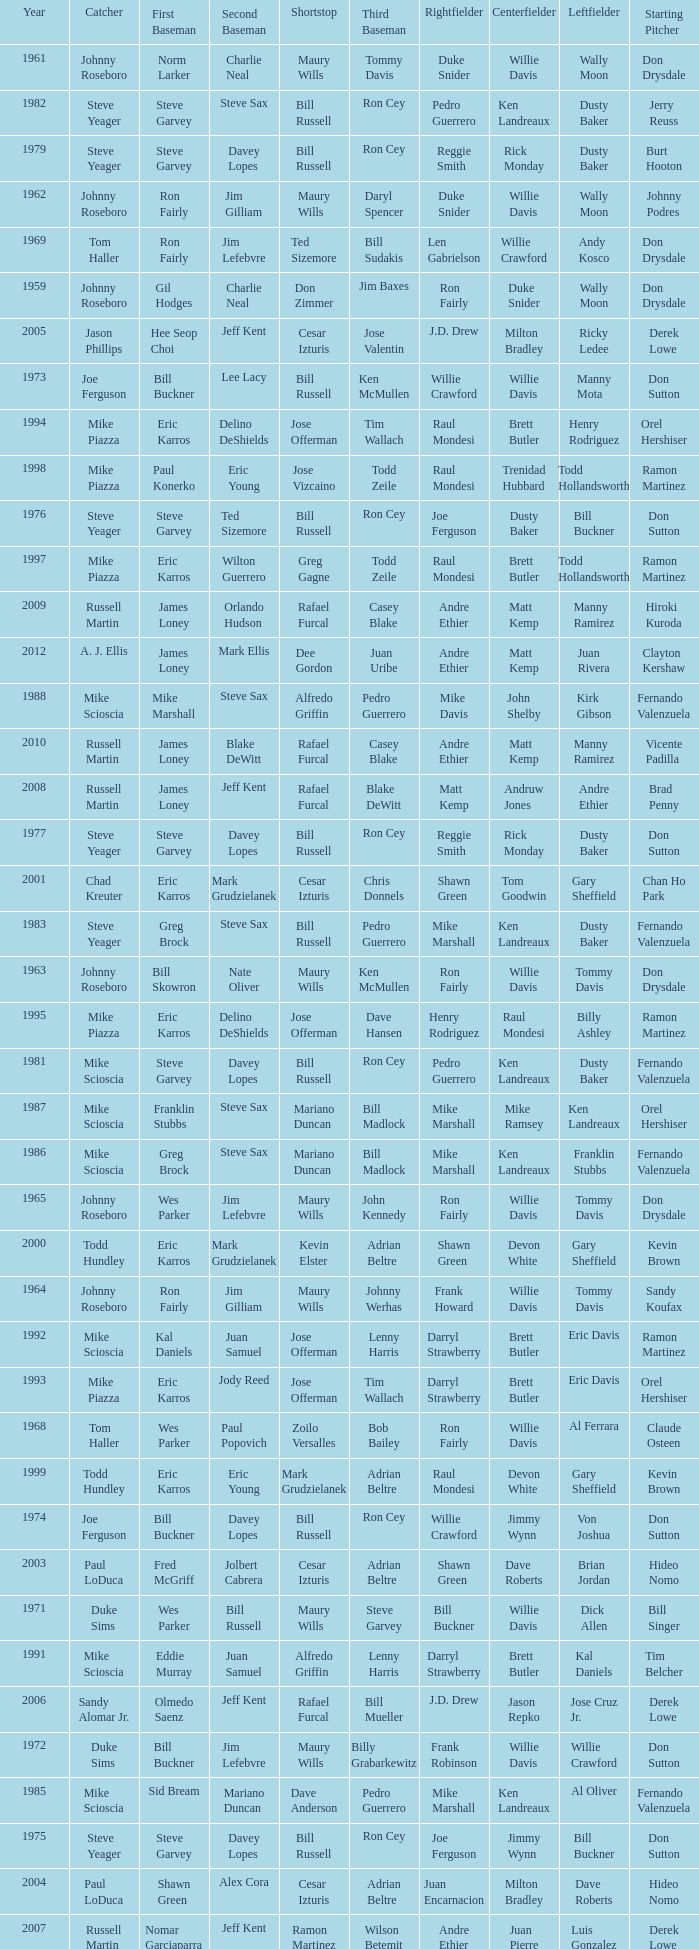Who was the SS when jim lefebvre was at 2nd, willie davis at CF, and don drysdale was the SP. Maury Wills. 